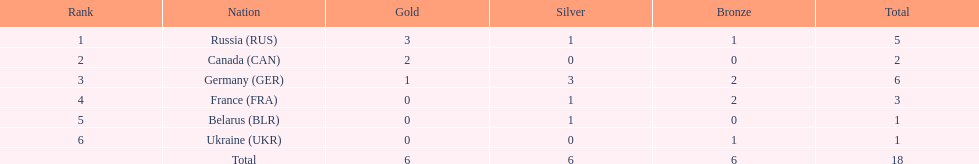Which nationalities competed? Russia (RUS), Canada (CAN), Germany (GER), France (FRA), Belarus (BLR), Ukraine (UKR). And how many gold medals did they obtain? 3, 2, 1, 0, 0, 0. What about silver medals? 1, 0, 3, 1, 1, 0. Would you mind parsing the complete table? {'header': ['Rank', 'Nation', 'Gold', 'Silver', 'Bronze', 'Total'], 'rows': [['1', 'Russia\xa0(RUS)', '3', '1', '1', '5'], ['2', 'Canada\xa0(CAN)', '2', '0', '0', '2'], ['3', 'Germany\xa0(GER)', '1', '3', '2', '6'], ['4', 'France\xa0(FRA)', '0', '1', '2', '3'], ['5', 'Belarus\xa0(BLR)', '0', '1', '0', '1'], ['6', 'Ukraine\xa0(UKR)', '0', '0', '1', '1'], ['', 'Total', '6', '6', '6', '18']]} And bronze? 1, 0, 2, 2, 0, 1. Which nationality only claimed gold medals? Canada (CAN). 